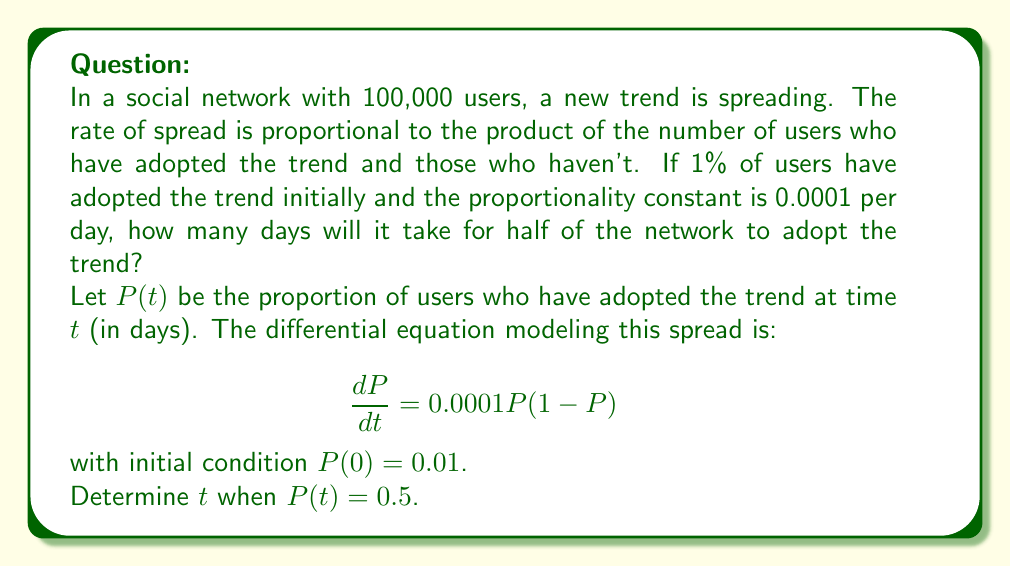Can you answer this question? To solve this problem, we'll use the logistic growth model, which is commonly used in epidemic modeling and can be applied to information spread in social networks.

1) The given differential equation is:

   $$\frac{dP}{dt} = 0.0001P(1-P)$$

2) The solution to this logistic equation is:

   $$P(t) = \frac{1}{1 + Ce^{-0.0001t}}$$

   where $C$ is a constant we need to determine.

3) Using the initial condition $P(0) = 0.01$, we can find $C$:

   $$0.01 = \frac{1}{1 + C}$$
   $$C = \frac{1-0.01}{0.01} = 99$$

4) Now our solution is:

   $$P(t) = \frac{1}{1 + 99e^{-0.0001t}}$$

5) We want to find $t$ when $P(t) = 0.5$. Let's substitute this:

   $$0.5 = \frac{1}{1 + 99e^{-0.0001t}}$$

6) Solving for $t$:

   $$1 + 99e^{-0.0001t} = 2$$
   $$99e^{-0.0001t} = 1$$
   $$e^{-0.0001t} = \frac{1}{99}$$
   $$-0.0001t = \ln(\frac{1}{99})$$
   $$t = -\frac{\ln(\frac{1}{99})}{0.0001} = \frac{\ln(99)}{0.0001}$$

7) Calculating this value:

   $$t = \frac{4.59512}{0.0001} \approx 45951.2$$

Therefore, it will take approximately 45,951 days for half of the network to adopt the trend.
Answer: 45,951 days 